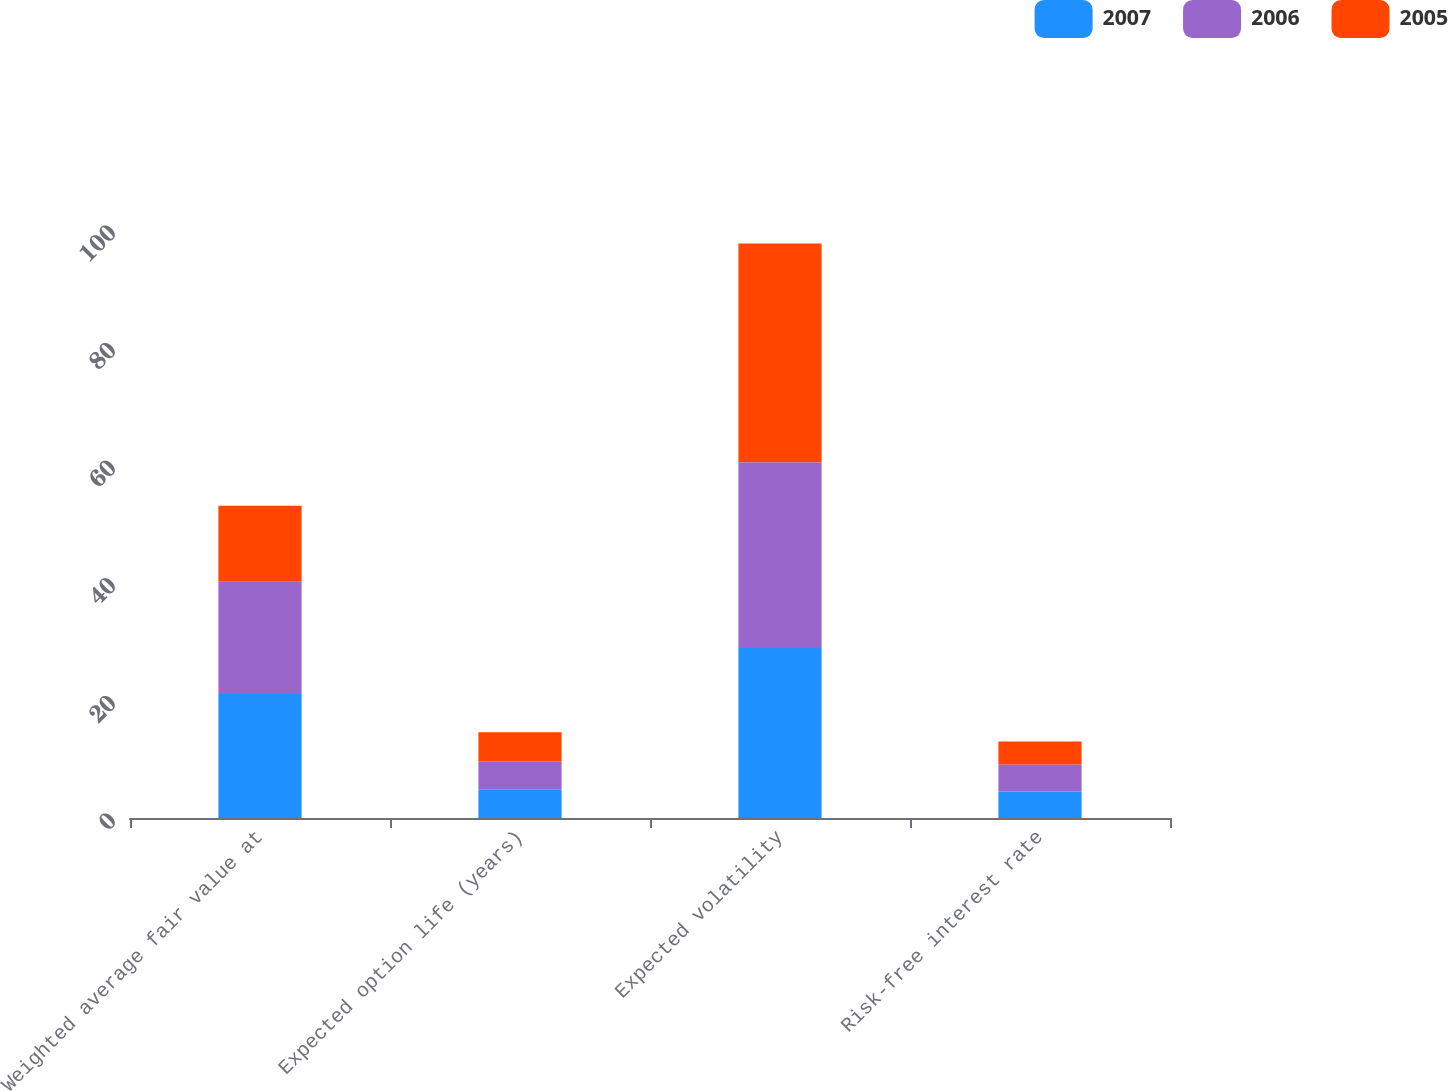Convert chart to OTSL. <chart><loc_0><loc_0><loc_500><loc_500><stacked_bar_chart><ecel><fcel>Weighted average fair value at<fcel>Expected option life (years)<fcel>Expected volatility<fcel>Risk-free interest rate<nl><fcel>2007<fcel>21.07<fcel>4.8<fcel>28.9<fcel>4.5<nl><fcel>2006<fcel>19.1<fcel>4.8<fcel>31.6<fcel>4.6<nl><fcel>2005<fcel>12.93<fcel>5<fcel>37.2<fcel>3.9<nl></chart> 